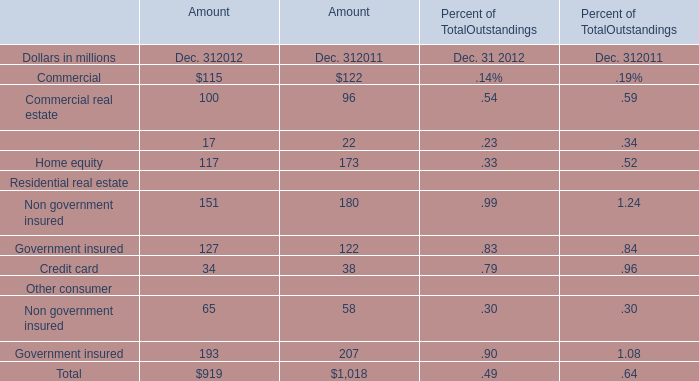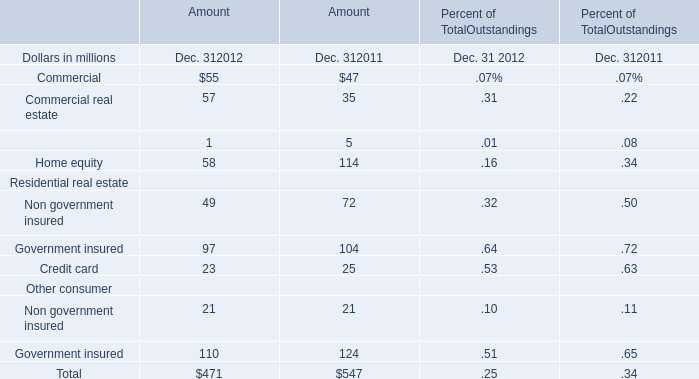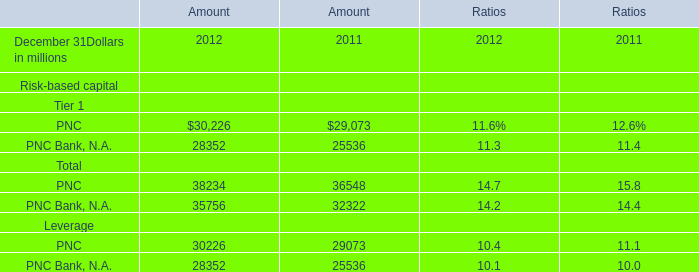How many Residential real estate exceed the average of Residential real estate in 2012? 
Computations: (((49 + 97) + 23) / 3)
Answer: 56.33333. 